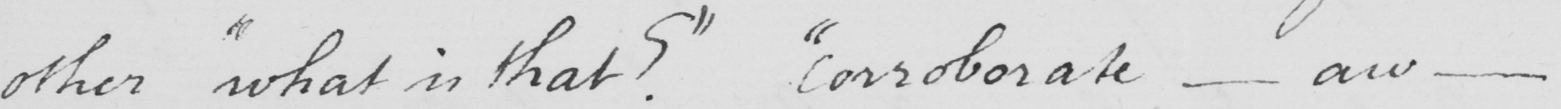What is written in this line of handwriting? other  " what is that ?  "   " corroborate  _  aw  _ 